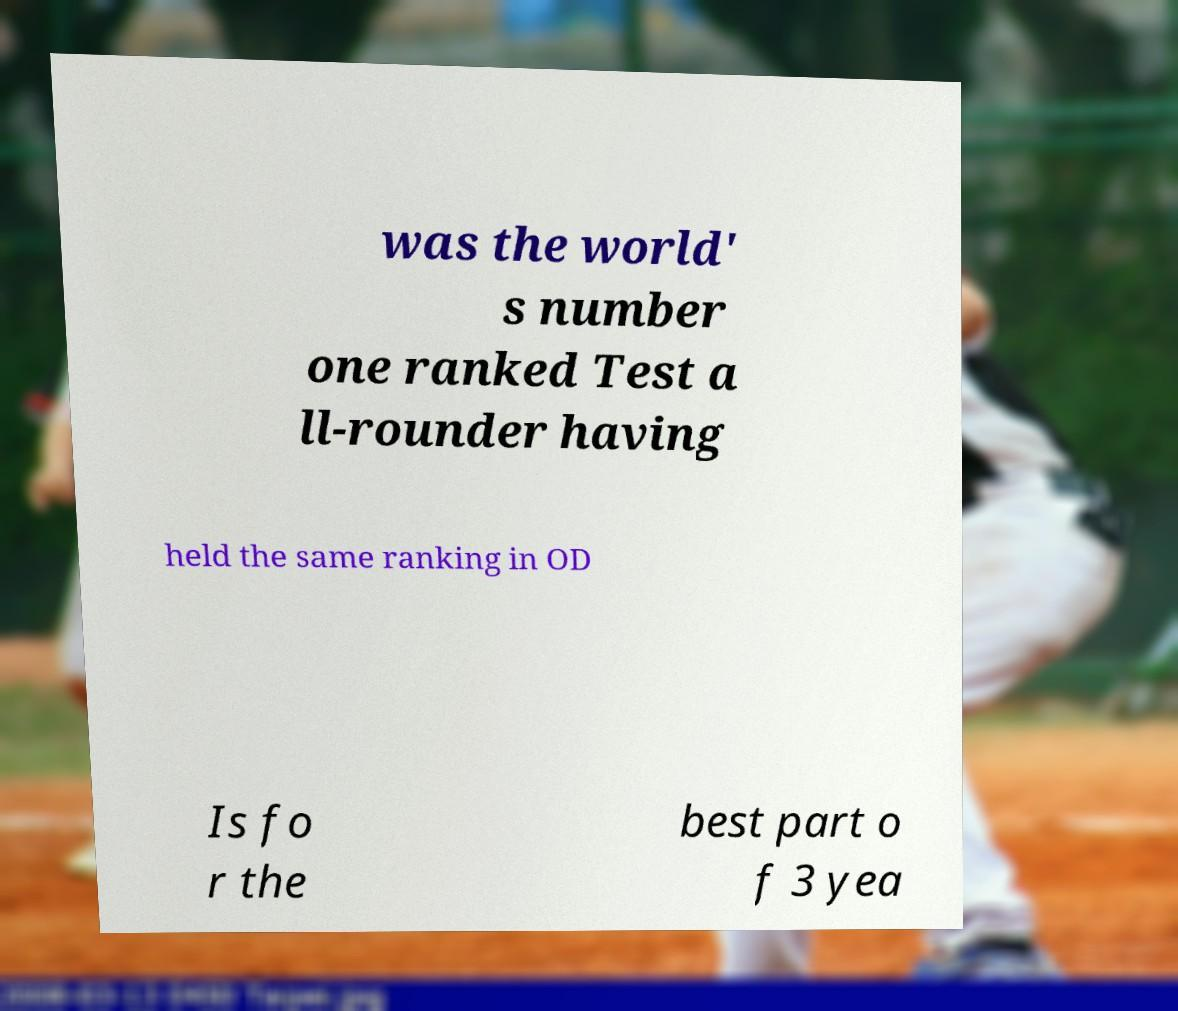Could you assist in decoding the text presented in this image and type it out clearly? was the world' s number one ranked Test a ll-rounder having held the same ranking in OD Is fo r the best part o f 3 yea 